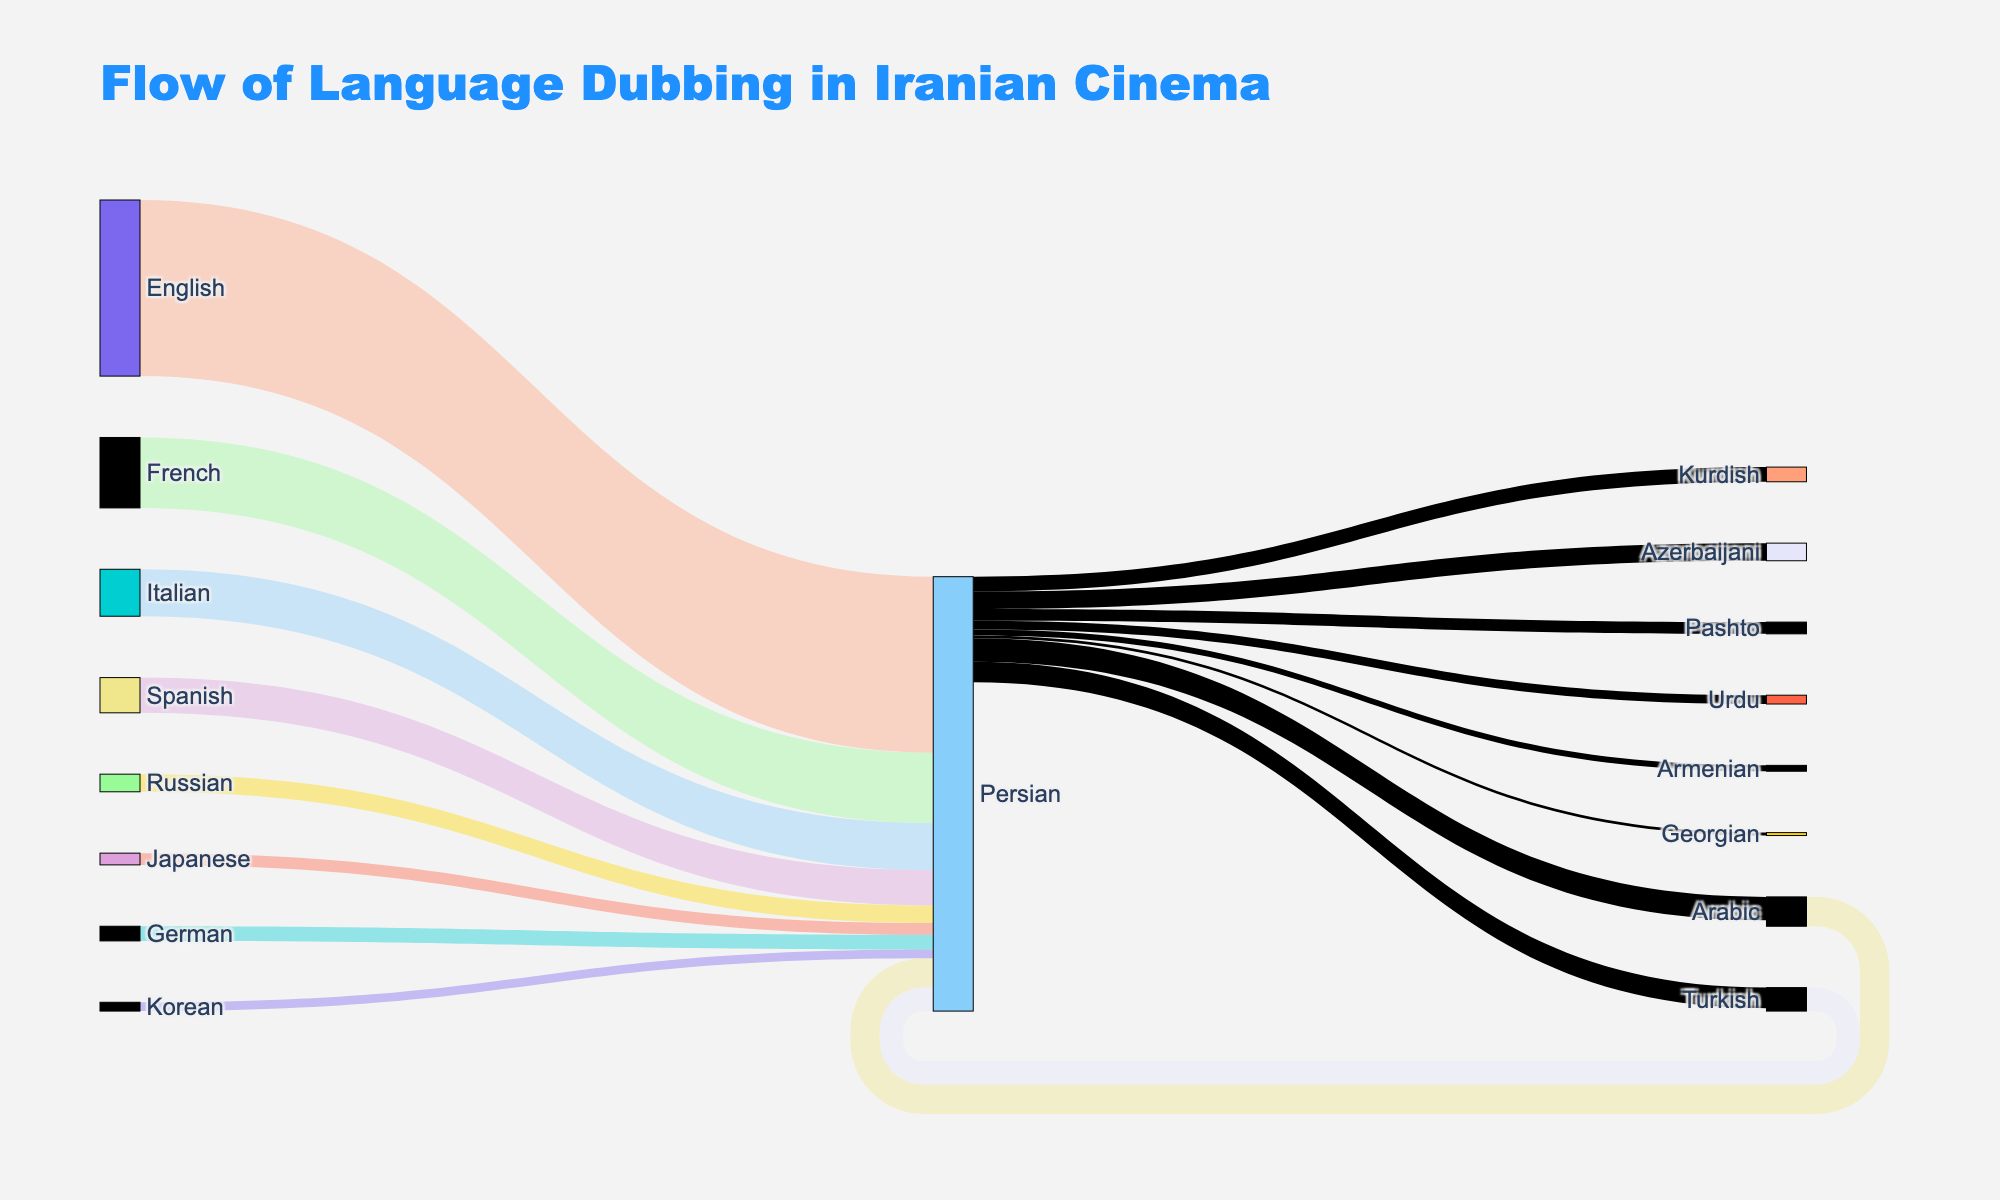what is the title of the figure? The title of the figure is displayed at the top and reads, "Flow of Language Dubbing in Iranian Cinema."
Answer: Flow of Language Dubbing in Iranian Cinema which source language has the highest dubbing flow into Persian? By looking at the widths of the flow lines leading to "Persian," the widest line comes from "English," indicating it has the highest dubbing flow.
Answer: English how many target languages are present in the plot? Counting the unique target languages listed, which are Persian, Arabic, Turkish, Azerbaijani, Kurdish, Pashto, Urdu, Armenian, and Georgian, there are a total of 9 target languages.
Answer: 9 what is the total number of movies dubbed from English? The value next to the flow from English to Persian is 300, meaning a total of 300 movies are dubbed from English into Persian.
Answer: 300 which language has the least number of movies dubbed into Persian? The smallest flow value going into Persian is from Korean, with a value of 15, indicating the least number of movies dubbed into Persian from Korean.
Answer: Korean what percentage of total movies are dubbed from Spanish to Persian? The flow from Spanish to Persian is 60. The total sum of movies dubbed into Persian is 300+120+80+60+50+40+30+25+20+15=740. The percentage is therefore (60/740) * 100 = 8.11%.
Answer: 8.11% compare the number of movies dubbed from French to Persian and Persian to Turkish? The flow from French to Persian is 120, and the flow from Persian to Turkish is 35. Comparing these, the number of movies dubbed from French to Persian (120) is much higher than those dubbed from Persian to Turkish (35).
Answer: French to Persian which languages have both inflow and outflow of dubbed movies? By observing the nodes with both incoming and outgoing arrows, "Persian" has inflow from multiple languages and outflow to multiple languages.
Answer: Persian among the inflows to Persian, which language has almost the same value as the outflow to Turkish? The value of outflow from Persian to Turkish is 35. Among the inflows to Persian, none of them are exactly 35, but Turkish inflow is close with a value of 40.
Answer: Turkish 